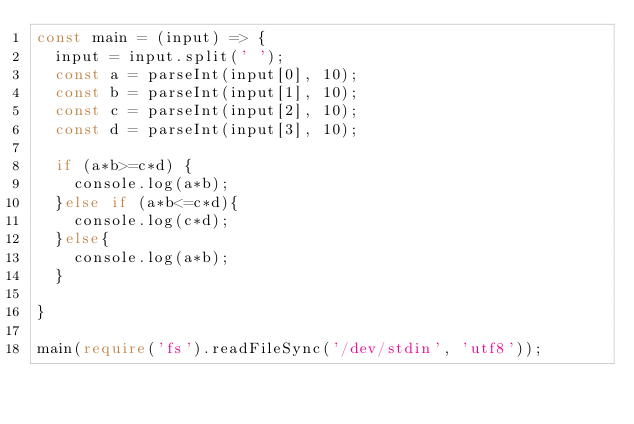Convert code to text. <code><loc_0><loc_0><loc_500><loc_500><_TypeScript_>const main = (input) => {
  input = input.split(' ');
  const a = parseInt(input[0], 10);
  const b = parseInt(input[1], 10);
  const c = parseInt(input[2], 10);
  const d = parseInt(input[3], 10);
  
  if (a*b>=c*d) {
    console.log(a*b);
  }else if (a*b<=c*d){
    console.log(c*d);
  }else{
    console.log(a*b);
  }
  
}
 
main(require('fs').readFileSync('/dev/stdin', 'utf8'));</code> 